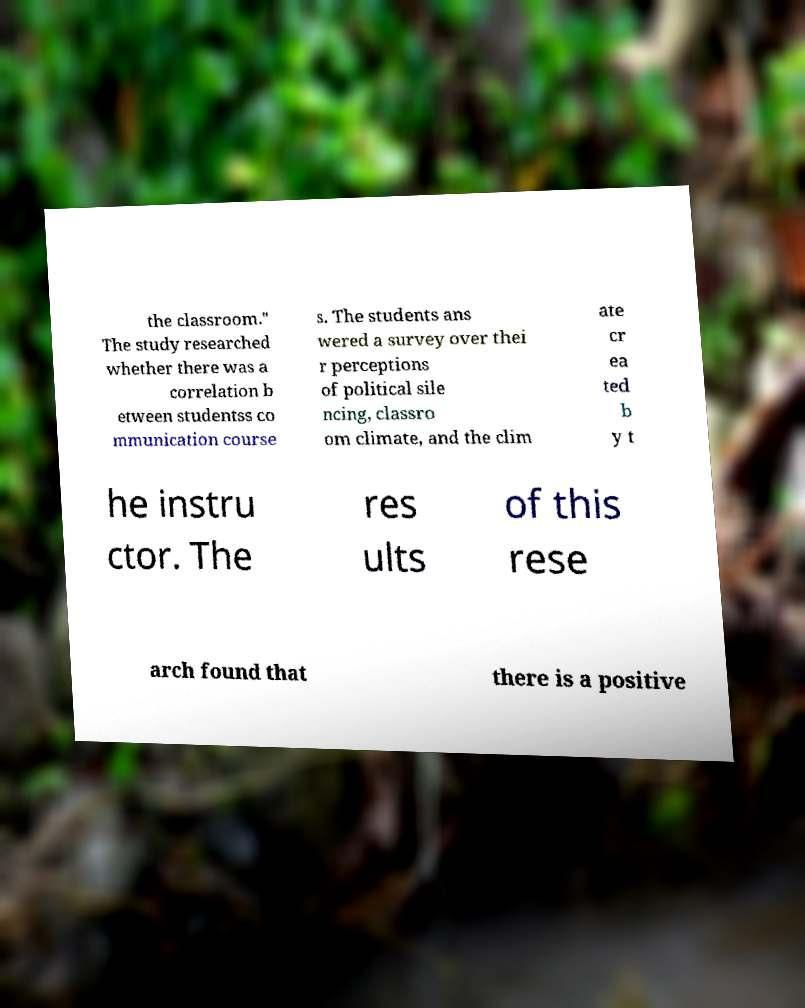There's text embedded in this image that I need extracted. Can you transcribe it verbatim? the classroom." The study researched whether there was a correlation b etween studentss co mmunication course s. The students ans wered a survey over thei r perceptions of political sile ncing, classro om climate, and the clim ate cr ea ted b y t he instru ctor. The res ults of this rese arch found that there is a positive 